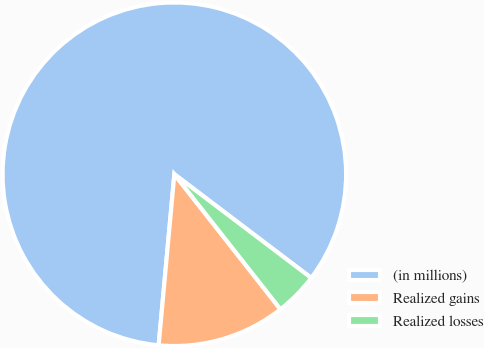<chart> <loc_0><loc_0><loc_500><loc_500><pie_chart><fcel>(in millions)<fcel>Realized gains<fcel>Realized losses<nl><fcel>83.86%<fcel>12.06%<fcel>4.08%<nl></chart> 